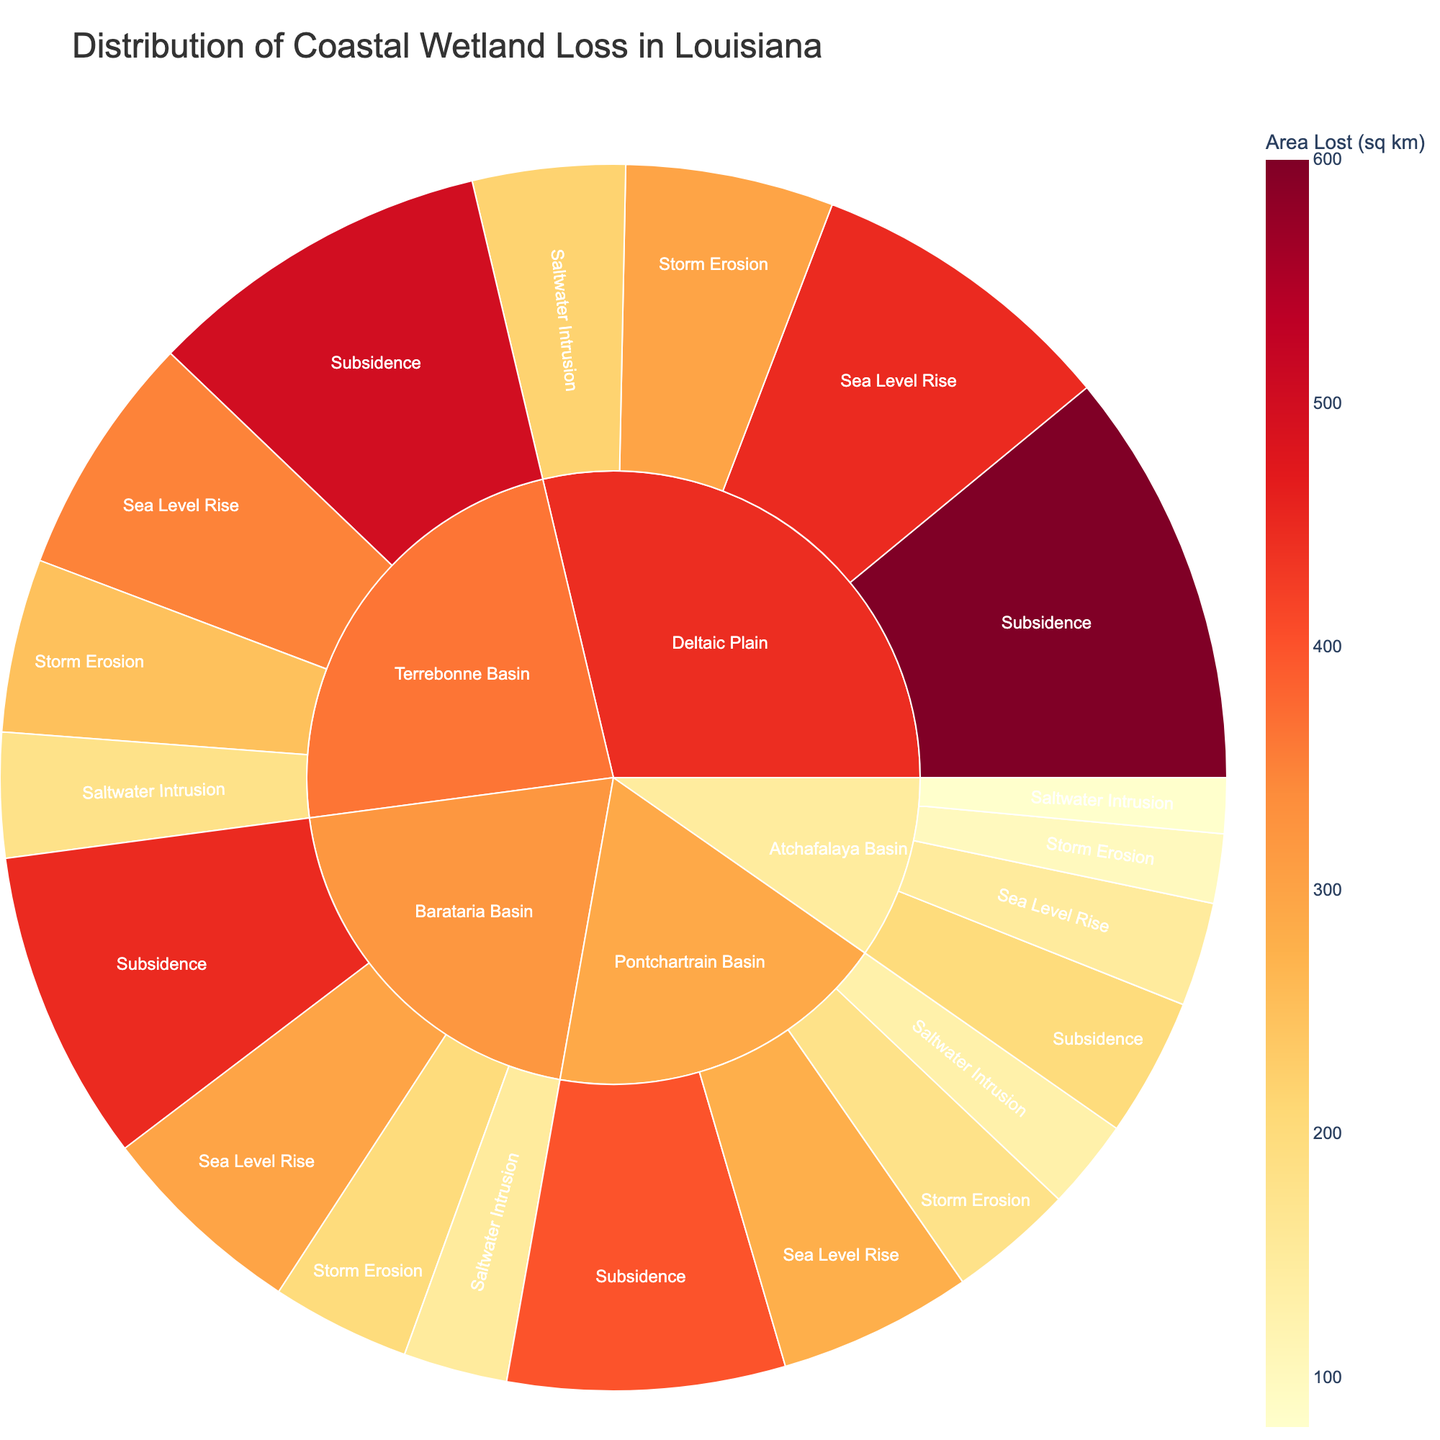Which region experienced the highest total area loss due to wetland loss? The Deltaic Plain has the largest segments in the sunburst plot. The color intensity indicates it has the highest values. Summing up the areas: 600 (Subsidence) + 450 (Sea Level Rise) + 300 (Storm Erosion) + 220 (Saltwater Intrusion) = 1570 sq km.
Answer: Deltaic Plain What is the total area lost in the Barataria Basin? Summing up the loss areas in the Barataria Basin: 450 (Subsidence) + 300 (Sea Level Rise) + 200 (Storm Erosion) + 150 (Saltwater Intrusion) = 1100 sq km.
Answer: 1100 sq km Which cause of wetland loss had the greatest impact in the Pontchartrain Basin? Among the causes in the Pontchartrain Basin, Subsidence has the highest value at 400 sq km, which is greater than the others: 280 (Sea Level Rise), 180 (Storm Erosion), 130 (Saltwater Intrusion).
Answer: Subsidence Compare the area lost due to Storm Erosion in the Terrebonne Basin and the Atchafalaya Basin. Which is higher? In the Terrebonne Basin, the area lost is 250 sq km while in the Atchafalaya Basin it is 100 sq km. 250 sq km is higher than 100 sq km.
Answer: Terrebonne Basin What is the difference in area lost to Saltwater Intrusion between the Deltaic Plain and the Pontchartrain Basin? Area lost in Deltaic Plain to Saltwater Intrusion is 220 sq km, and in Pontchartrain Basin it is 130 sq km. The difference is 220 - 130 = 90 sq km.
Answer: 90 sq km Which region has the least area loss due to Sea Level Rise? Sea Level Rise in the Atchafalaya Basin shows the smallest segment with 150 sq km, which is less than 300 in Barataria, 350 in Terrebonne, 280 in Pontchartrain and 450 in Deltaic.
Answer: Atchafalaya Basin If you sum the total areas lost due to Subsidence across all regions, what is the result? Sum of Subsidence areas: 450 (Barataria) + 500 (Terrebonne) + 400 (Pontchartrain) + 200 (Atchafalaya) + 600 (Deltaic Plain) = 2150 sq km.
Answer: 2150 sq km How does the area lost due to Sea Level Rise in the Barataria Basin compare to that in the Pontchartrain Basin? Barataria Basin lost 300 sq km, and Pontchartrain Basin lost 280 sq km. 300 sq km is greater than 280 sq km.
Answer: Barataria Basin Which cause of wetland loss is consistently the highest among all the regions? Comparing each cause across all the regions, Subsidence is consistently the highest in all regions: 450 (Barataria), 500 (Terrebonne), 400 (Pontchartrain), 200 (Atchafalaya), and 600 (Deltaic).
Answer: Subsidence What percentage of the total wetland loss in the Terrebonne Basin is due to Subsidence? Total loss in Terrebonne is 500 + 350 + 250 + 180 = 1280 sq km. Loss due to Subsidence is 500. Percentage is (500/1280) * 100% ≈ 39.06%.
Answer: 39.06% 